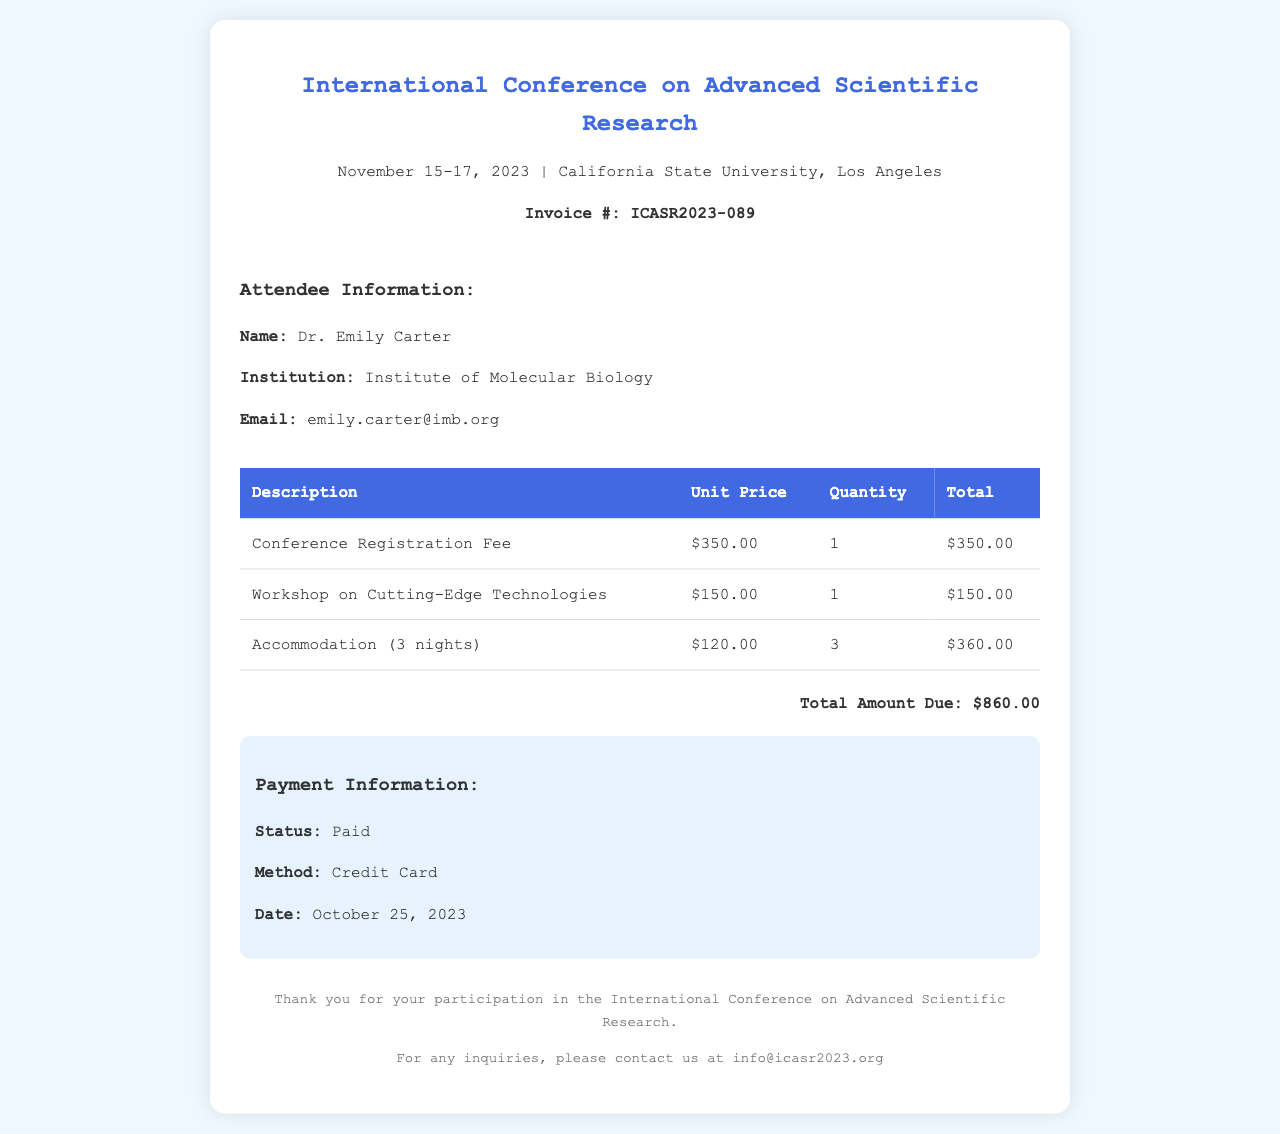What is the name of the conference? The name of the conference is stated in the header of the document.
Answer: International Conference on Advanced Scientific Research What is the total amount due? This is listed in the total section of the invoice details.
Answer: $860.00 What was the payment method used? The payment information section specifies the method used for payment.
Answer: Credit Card Who is the attendee? The attendee's name is mentioned in the attendee information section.
Answer: Dr. Emily Carter How many nights of accommodation were booked? The accommodation details indicate the duration of stay.
Answer: 3 nights What is the registration fee for the conference? The fee for registration is provided in the itemized list of charges.
Answer: $350.00 When was the payment made? The date of payment is listed in the payment information section.
Answer: October 25, 2023 What topics does the workshop cover? The description provides insight into the content of the workshop.
Answer: Cutting-Edge Technologies What institution is Dr. Emily Carter affiliated with? The affiliated institution is mentioned in the attendee information section.
Answer: Institute of Molecular Biology 